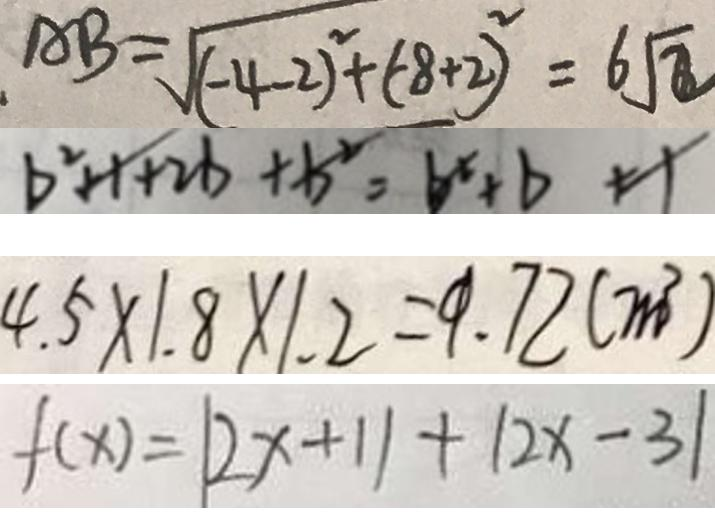<formula> <loc_0><loc_0><loc_500><loc_500>A B = \sqrt { ( - 4 - 2 ) ^ { 2 } + ( - 8 + 2 ) ^ { 2 } } = 6 \sqrt { 2 } 
 b ^ { 2 } + 1 + 2 b + b ^ { 2 } = b ^ { x } + b + 1 
 4 . 5 \times 1 . 8 \times 1 . 2 = 9 . 7 2 ( m ^ { 3 } ) 
 f ( x ) = \vert 2 x + 1 \vert + \vert 2 x - 3 \vert</formula> 